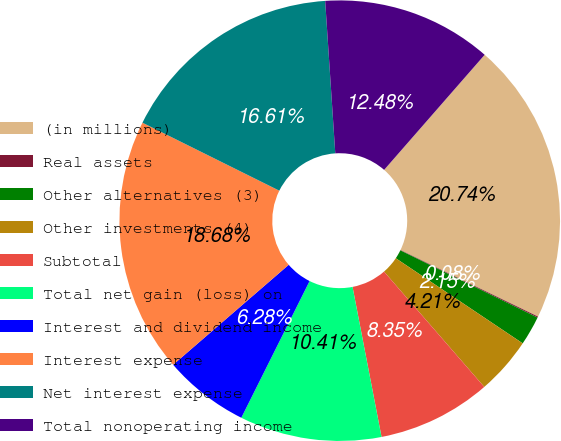Convert chart. <chart><loc_0><loc_0><loc_500><loc_500><pie_chart><fcel>(in millions)<fcel>Real assets<fcel>Other alternatives (3)<fcel>Other investments (4)<fcel>Subtotal<fcel>Total net gain (loss) on<fcel>Interest and dividend income<fcel>Interest expense<fcel>Net interest expense<fcel>Total nonoperating income<nl><fcel>20.74%<fcel>0.08%<fcel>2.15%<fcel>4.21%<fcel>8.35%<fcel>10.41%<fcel>6.28%<fcel>18.68%<fcel>16.61%<fcel>12.48%<nl></chart> 